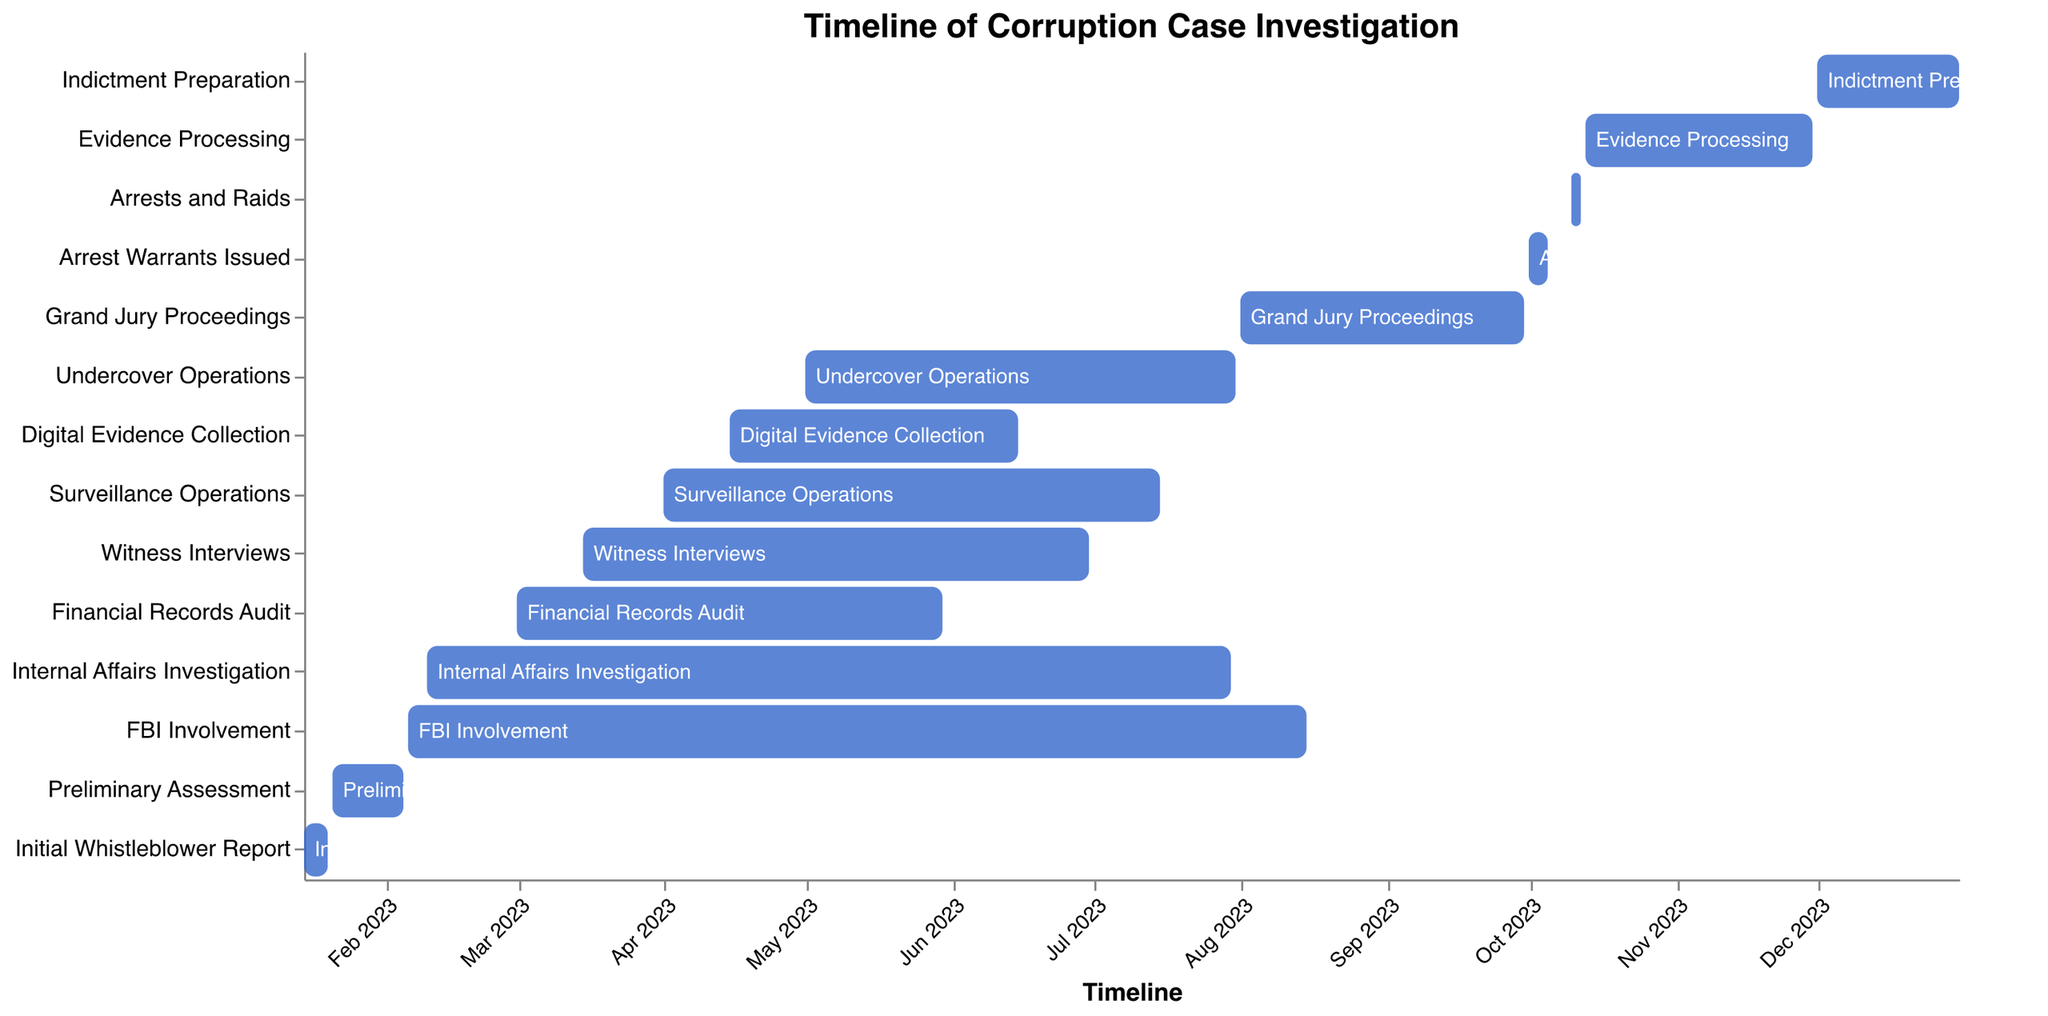Which investigation task started first? By observing the start times on the Gantt chart, the task "Initial Whistleblower Report" has the earliest start date of January 15, 2023.
Answer: Initial Whistleblower Report Which tasks were ongoing during March 2023? Look for tasks with a start date before or during March and an end date after March starts. These are:
- FBI Involvement (Feb 6 - Aug 15)
- Internal Affairs Investigation (Feb 10 - Jul 30)
- Financial Records Audit (Mar 1 - May 30)
- Witness Interviews (Mar 15 - Jun 30)
Thus, during March 2023, these tasks were ongoing.
Answer: FBI Involvement, Internal Affairs Investigation, Financial Records Audit, Witness Interviews What is the duration of the "FBI Involvement" task? The "FBI Involvement" task starts on February 6, 2023, and ends on August 15, 2023. To calculate the duration, count the days between these dates. The duration is 191 days.
Answer: 191 days Which two tasks have the longest overlap in their timelines? By visually inspecting the Gantt chart, the "FBI Involvement" and "Internal Affairs Investigation" tasks overlap the most. "FBI Involvement" (Feb 6 - Aug 15) and "Internal Affairs Investigation" (Feb 10 - Jul 30) overlap from Feb 10 to Jul 30, which is 171 days.
Answer: FBI Involvement and Internal Affairs Investigation How many tasks are completed before October 2023? Observing the end dates, the tasks completed before October 2023 are:
- Initial Whistleblower Report (Jan 20)
- Preliminary Assessment (Feb 5)
- Financial Records Audit (May 30)
- Witness Interviews (Jun 30)
- Surveillance Operations (Jul 15)
- Digital Evidence Collection (Jun 15)
- Internal Affairs Investigation (Jul 30)
- FBI Involvement (Aug 15)
- Undercover Operations (Jul 31)
- Grand Jury Proceedings (Sep 30)
Thus, 10 tasks are completed before October 2023.
Answer: 10 Which tasks involved evidence gathering through interviews? By cross-referencing the task names, "Witness Interviews" clearly involves evidence gathering through interviews.
Answer: Witness Interviews What task directly follows "Arrests and Raids"? By looking at the timeline, the task starting immediately after "Arrests and Raids" (ends Oct 12) is "Evidence Processing" which starts on October 13.
Answer: Evidence Processing Are there any tasks that start after their preceding task ends and don't overlap? Provide an example. Evaluating the tasks, "Arrests and Raids" ends on October 12, and "Evidence Processing" starts on October 13. These tasks have no overlap.
Answer: Arrests and Raids and Evidence Processing 